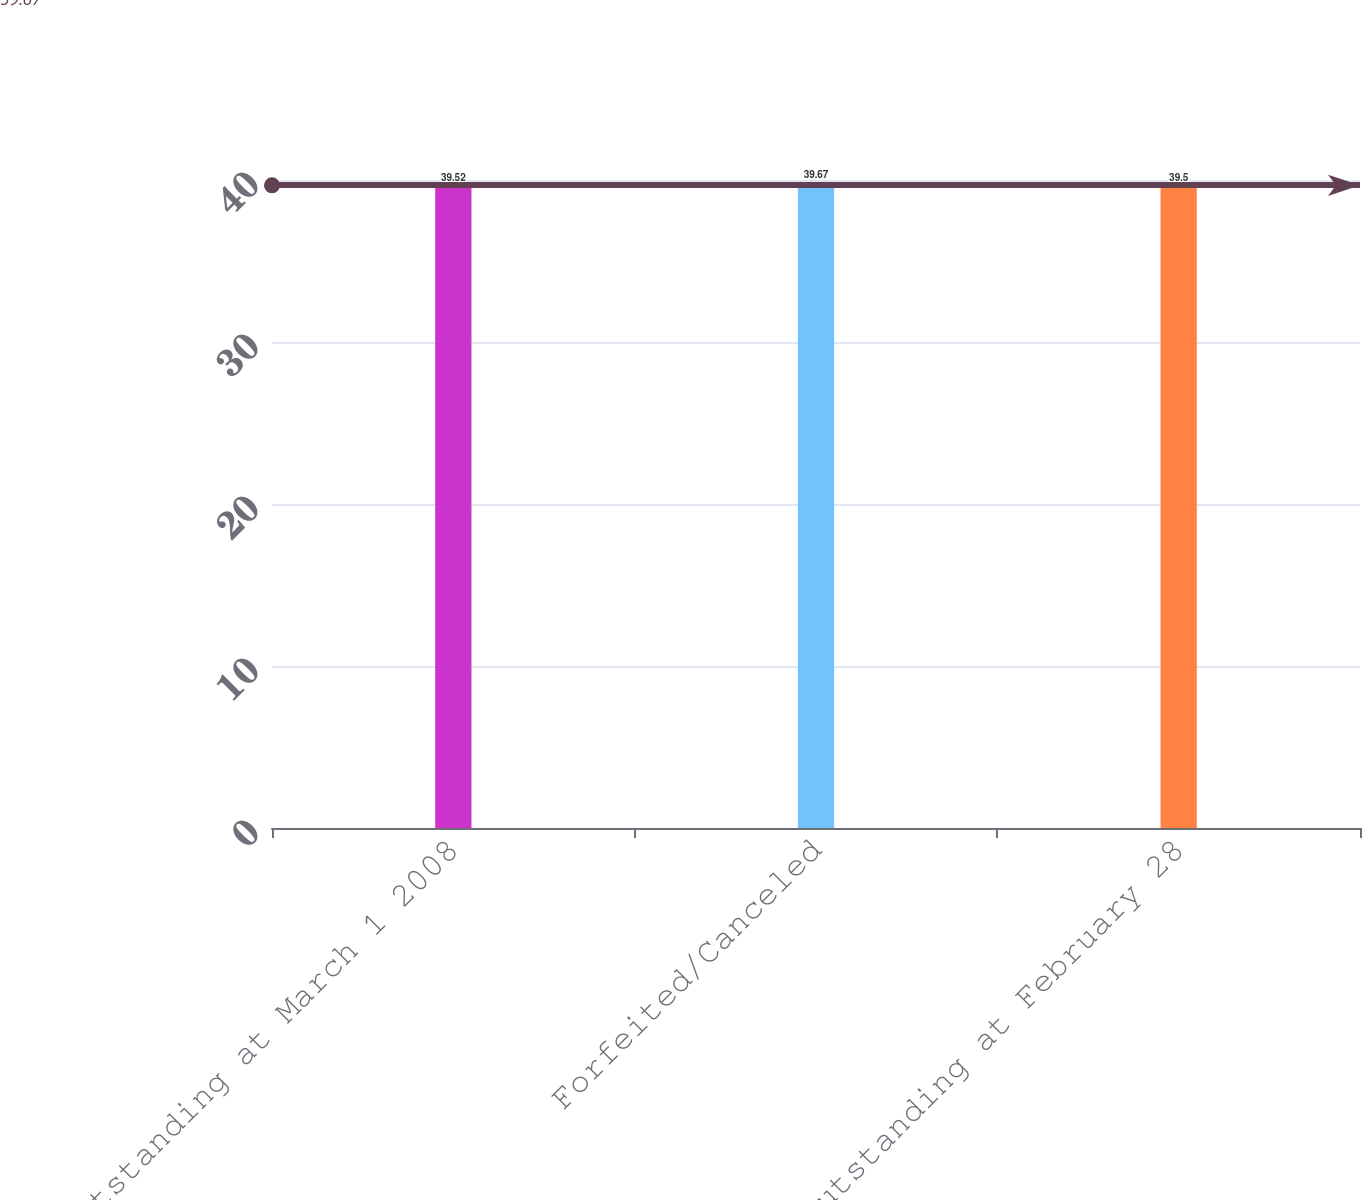<chart> <loc_0><loc_0><loc_500><loc_500><bar_chart><fcel>Outstanding at March 1 2008<fcel>Forfeited/Canceled<fcel>Outstanding at February 28<nl><fcel>39.52<fcel>39.67<fcel>39.5<nl></chart> 